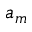Convert formula to latex. <formula><loc_0><loc_0><loc_500><loc_500>a _ { m }</formula> 